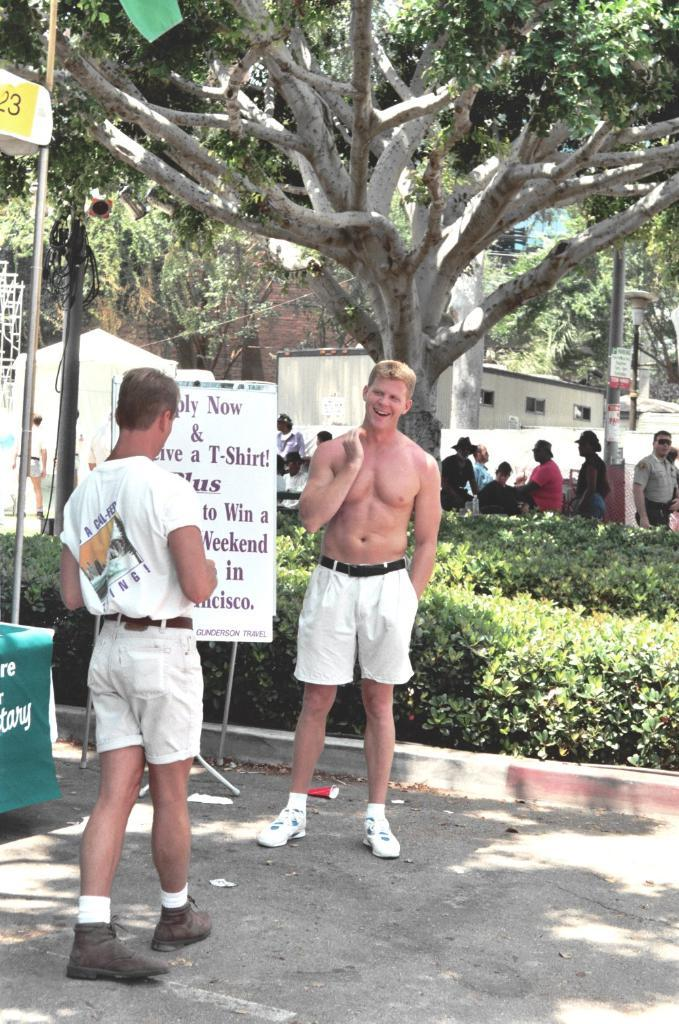<image>
Create a compact narrative representing the image presented. Two men are standing by a sign that says Apply Now. 